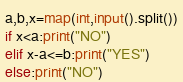Convert code to text. <code><loc_0><loc_0><loc_500><loc_500><_Python_>a,b,x=map(int,input().split())
if x<a:print("NO")
elif x-a<=b:print("YES")
else:print("NO")</code> 